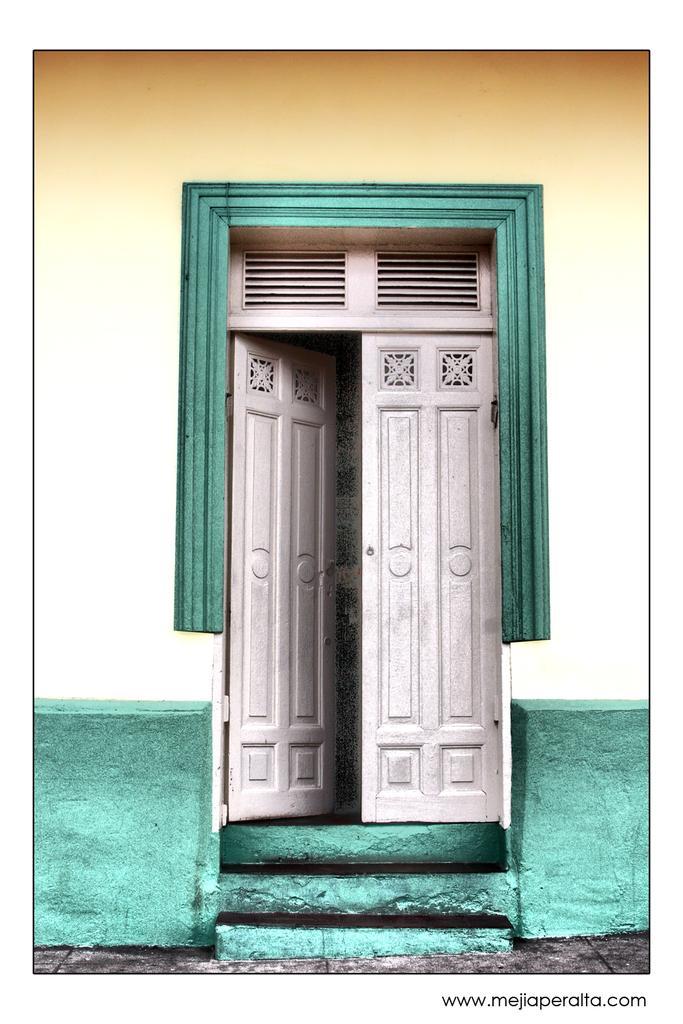In one or two sentences, can you explain what this image depicts? In this image we can see there is a wall. There are doors and stairs. 